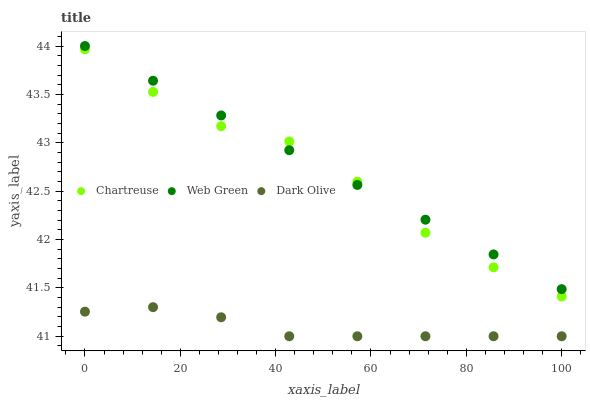Does Dark Olive have the minimum area under the curve?
Answer yes or no. Yes. Does Web Green have the maximum area under the curve?
Answer yes or no. Yes. Does Web Green have the minimum area under the curve?
Answer yes or no. No. Does Dark Olive have the maximum area under the curve?
Answer yes or no. No. Is Web Green the smoothest?
Answer yes or no. Yes. Is Chartreuse the roughest?
Answer yes or no. Yes. Is Dark Olive the smoothest?
Answer yes or no. No. Is Dark Olive the roughest?
Answer yes or no. No. Does Dark Olive have the lowest value?
Answer yes or no. Yes. Does Web Green have the lowest value?
Answer yes or no. No. Does Web Green have the highest value?
Answer yes or no. Yes. Does Dark Olive have the highest value?
Answer yes or no. No. Is Dark Olive less than Chartreuse?
Answer yes or no. Yes. Is Web Green greater than Dark Olive?
Answer yes or no. Yes. Does Chartreuse intersect Web Green?
Answer yes or no. Yes. Is Chartreuse less than Web Green?
Answer yes or no. No. Is Chartreuse greater than Web Green?
Answer yes or no. No. Does Dark Olive intersect Chartreuse?
Answer yes or no. No. 